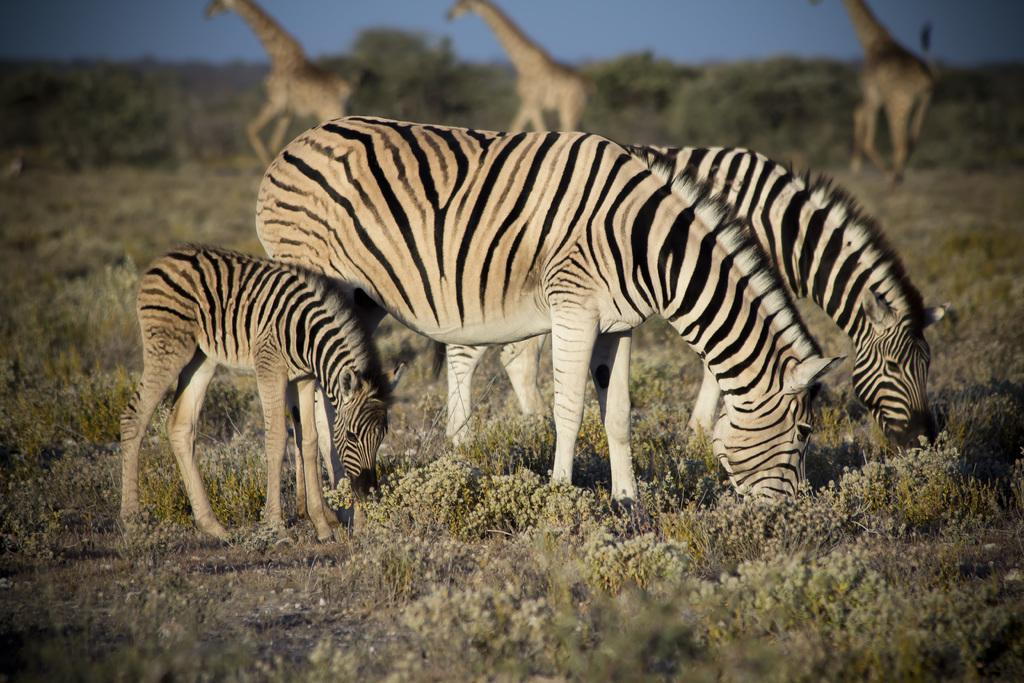What animals can be seen in the image? There are zebras and giraffes in the image. What are the zebras doing in the image? The zebras are eating grass in the image. What can be seen in the background of the image? There are trees and the sky visible in the background of the image. What type of chain can be seen hanging from the trees in the image? There is no chain present in the image; it features zebras and giraffes in a natural setting with trees and the sky visible in the background. 